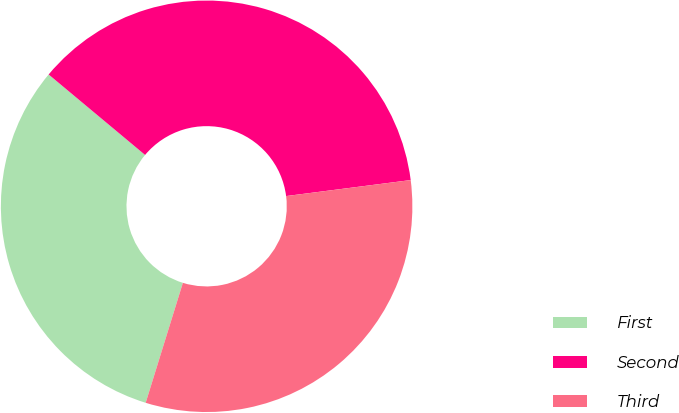<chart> <loc_0><loc_0><loc_500><loc_500><pie_chart><fcel>First<fcel>Second<fcel>Third<nl><fcel>31.28%<fcel>36.9%<fcel>31.82%<nl></chart> 